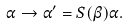Convert formula to latex. <formula><loc_0><loc_0><loc_500><loc_500>\alpha \to \alpha ^ { \prime } = S ( \beta ) \alpha .</formula> 